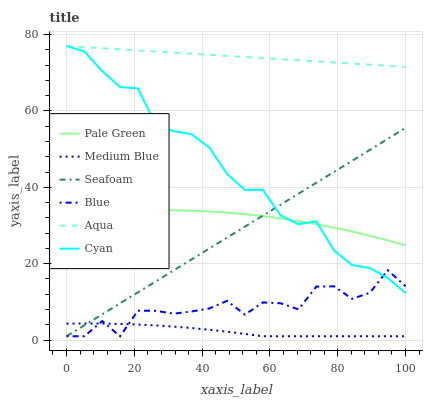Does Medium Blue have the minimum area under the curve?
Answer yes or no. Yes. Does Aqua have the maximum area under the curve?
Answer yes or no. Yes. Does Aqua have the minimum area under the curve?
Answer yes or no. No. Does Medium Blue have the maximum area under the curve?
Answer yes or no. No. Is Aqua the smoothest?
Answer yes or no. Yes. Is Blue the roughest?
Answer yes or no. Yes. Is Medium Blue the smoothest?
Answer yes or no. No. Is Medium Blue the roughest?
Answer yes or no. No. Does Aqua have the lowest value?
Answer yes or no. No. Does Cyan have the highest value?
Answer yes or no. Yes. Does Medium Blue have the highest value?
Answer yes or no. No. Is Medium Blue less than Cyan?
Answer yes or no. Yes. Is Aqua greater than Blue?
Answer yes or no. Yes. Does Blue intersect Medium Blue?
Answer yes or no. Yes. Is Blue less than Medium Blue?
Answer yes or no. No. Is Blue greater than Medium Blue?
Answer yes or no. No. Does Medium Blue intersect Cyan?
Answer yes or no. No. 